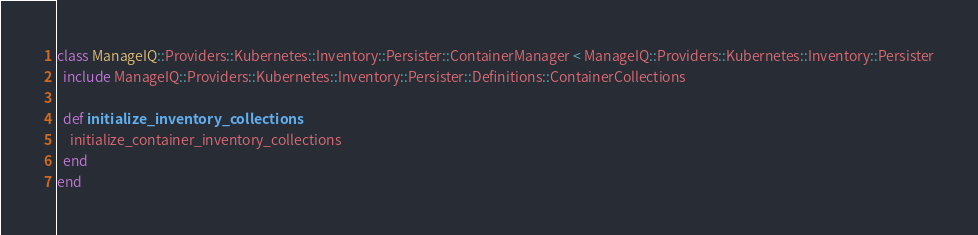<code> <loc_0><loc_0><loc_500><loc_500><_Ruby_>class ManageIQ::Providers::Kubernetes::Inventory::Persister::ContainerManager < ManageIQ::Providers::Kubernetes::Inventory::Persister
  include ManageIQ::Providers::Kubernetes::Inventory::Persister::Definitions::ContainerCollections

  def initialize_inventory_collections
    initialize_container_inventory_collections
  end
end
</code> 